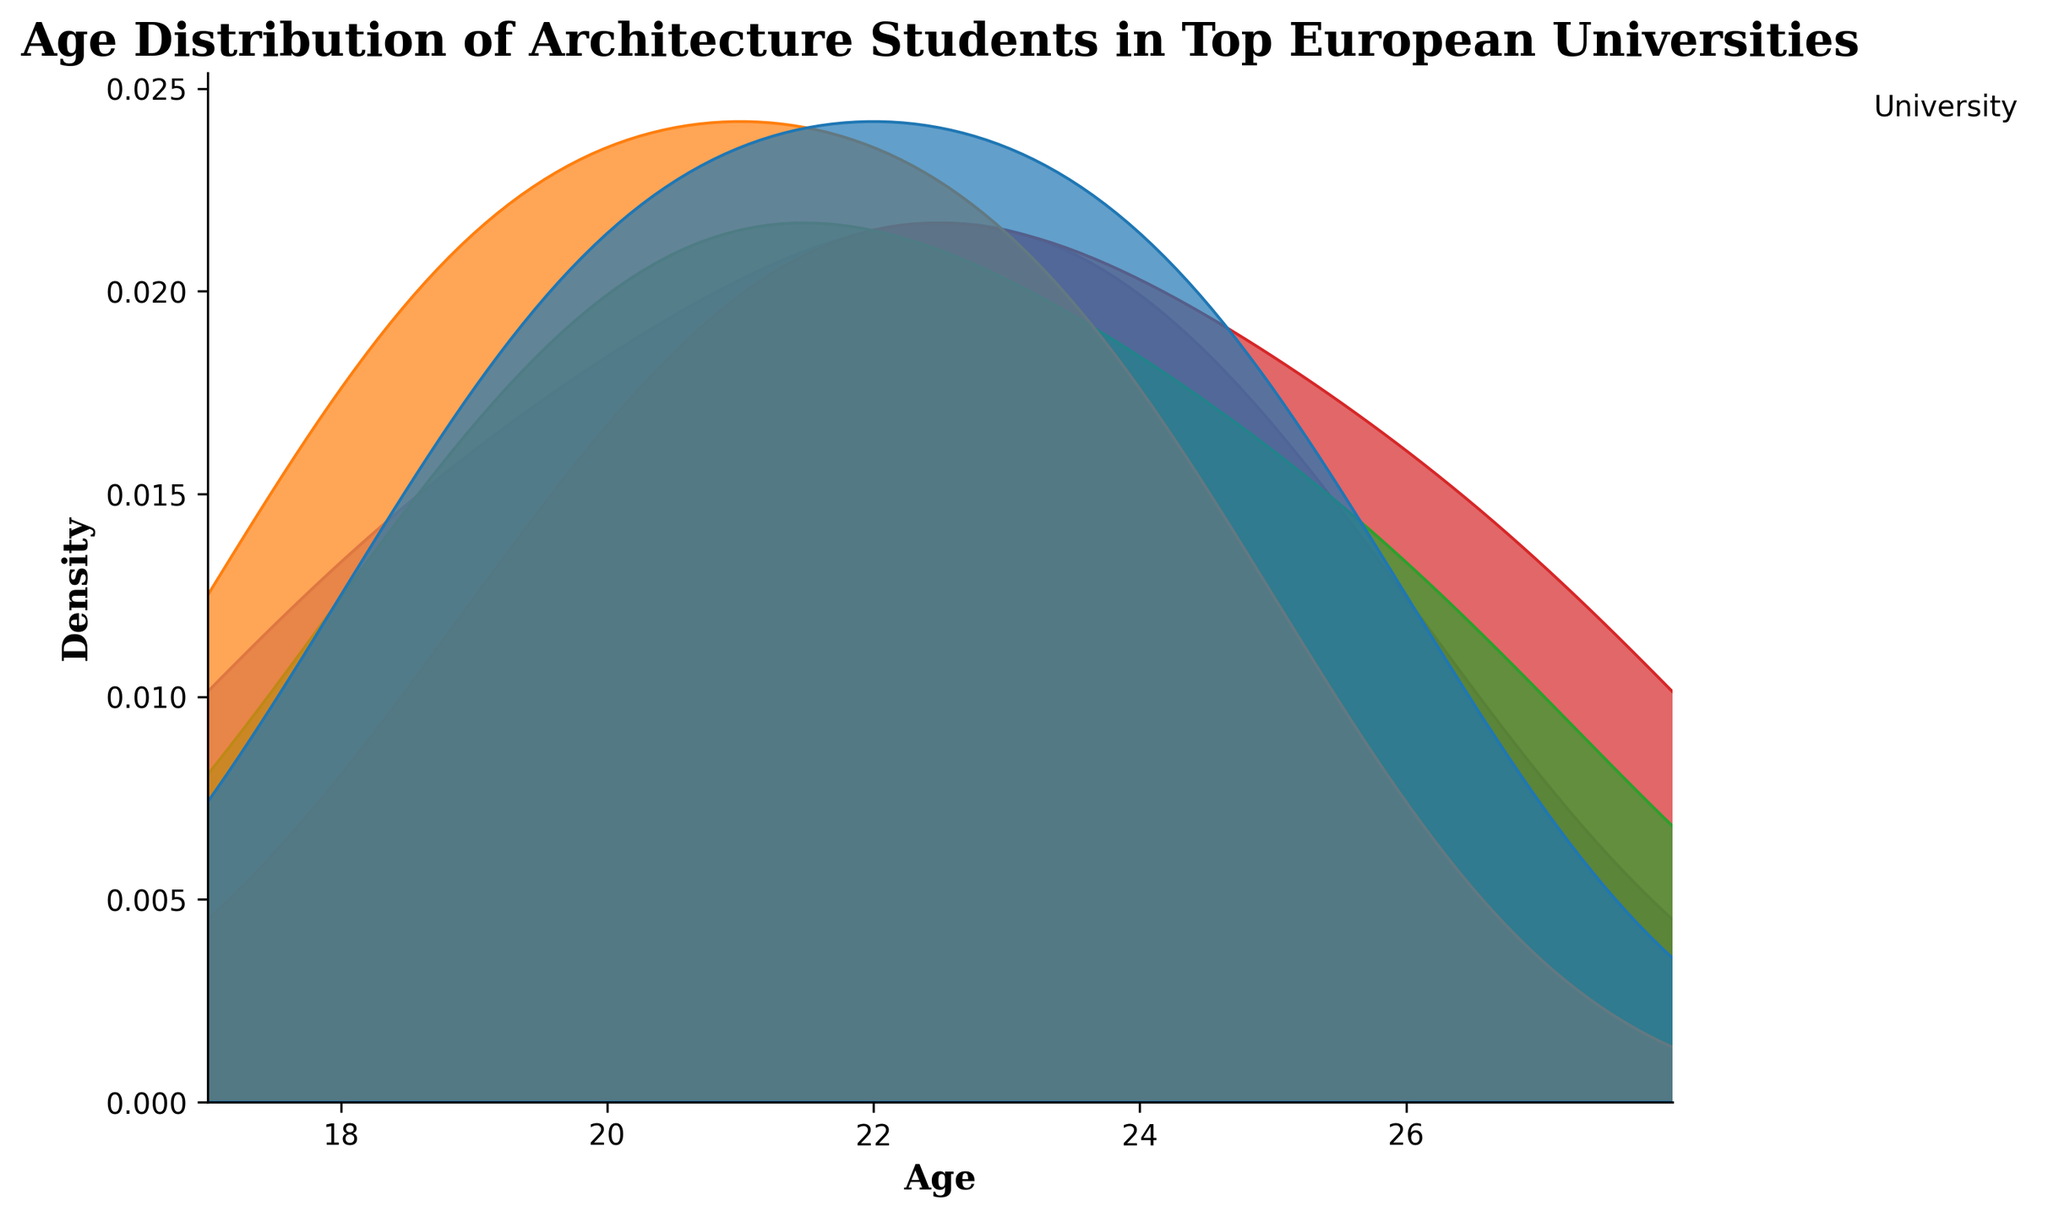What's the title of the figure? The title of the figure is located at the top and typically summarizes the key information being conveyed by the plot.
Answer: Age Distribution of Architecture Students in Top European Universities What's the age range displayed in the plot? The age range can be determined by looking at the x-axis, which shows the distribution of ages. The labels on the x-axis indicate the minimum and maximum ages plotted.
Answer: 17 to 28 Which university has the most skewed age distribution? A skewed age distribution will show a density curve that is not symmetrical. By examining the shape of each university's density curve, we can identify the one with the most asymmetrical distribution. For example, if one university's curve is heavily leaning towards younger or older ages, it is skewed.
Answer: TU Munich Does any university have an age peak at 24? An age peak can be identified as a local maximum in the density curve at that specific age. By looking at the height of the density at age 24 for each university, we can see if any have a noticeable peak.
Answer: TU Delft and TU Munich Which universities have a density peak at age 21? Density peaks are the points where the density is the highest along the curve. Observing the height at age 21 on the plot for each university's distribution can show if any universities have peaks there.
Answer: ETH Zurich, UCL Bartlett, Politecnico di Milano Are there any universities with density at age 27? To determine if any universities have a presence at age 27, observe the density values at that age point. If the distribution curve is above zero at age 27, it indicates density.
Answer: TU Munich Which university shows the widest age range among the students? The widest age range can be found by checking the span of ages covered by the density curve of each university. The university that covers the broadest span of ages without the curve approaching zero shows the widest range.
Answer: TU Munich Is there any university whose age distribution overlaps at age 19? Overlap in age distributions can be checked by looking at whether two or more density curves are above zero at age 19.
Answer: ETH Zurich, UCL Bartlett Compare the density of ETH Zurich and TU Delft at age 22. Which is higher? To compare densities at a specific age, look at the height of the density curves for both universities at that age. The one with the higher curve at age 22 has a higher density.
Answer: TU Delft What age has the highest density for UCL Bartlett? The highest density for a university is at the peak of its density curve. For UCL Bartlett, observe the age where the curve reaches its maximum height.
Answer: 21 